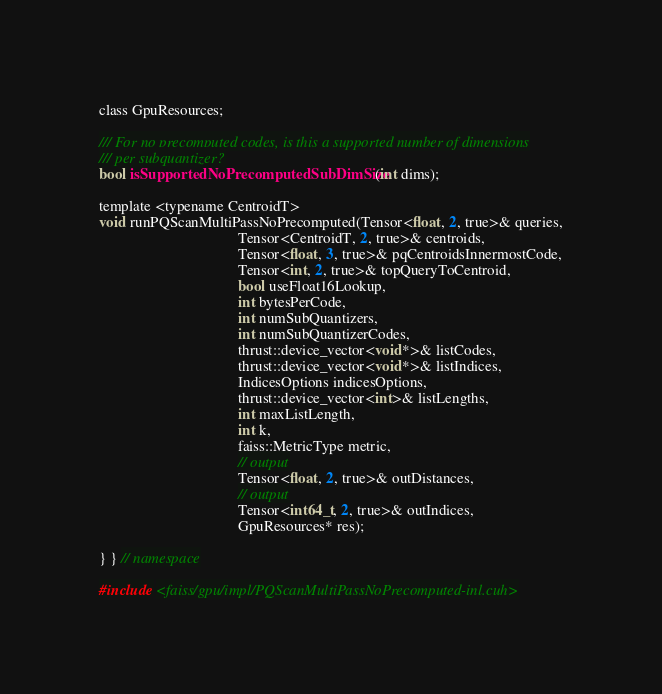Convert code to text. <code><loc_0><loc_0><loc_500><loc_500><_Cuda_>
class GpuResources;

/// For no precomputed codes, is this a supported number of dimensions
/// per subquantizer?
bool isSupportedNoPrecomputedSubDimSize(int dims);

template <typename CentroidT>
void runPQScanMultiPassNoPrecomputed(Tensor<float, 2, true>& queries,
                                     Tensor<CentroidT, 2, true>& centroids,
                                     Tensor<float, 3, true>& pqCentroidsInnermostCode,
                                     Tensor<int, 2, true>& topQueryToCentroid,
                                     bool useFloat16Lookup,
                                     int bytesPerCode,
                                     int numSubQuantizers,
                                     int numSubQuantizerCodes,
                                     thrust::device_vector<void*>& listCodes,
                                     thrust::device_vector<void*>& listIndices,
                                     IndicesOptions indicesOptions,
                                     thrust::device_vector<int>& listLengths,
                                     int maxListLength,
                                     int k,
                                     faiss::MetricType metric,
                                     // output
                                     Tensor<float, 2, true>& outDistances,
                                     // output
                                     Tensor<int64_t, 2, true>& outIndices,
                                     GpuResources* res);

} } // namespace

#include <faiss/gpu/impl/PQScanMultiPassNoPrecomputed-inl.cuh>
</code> 